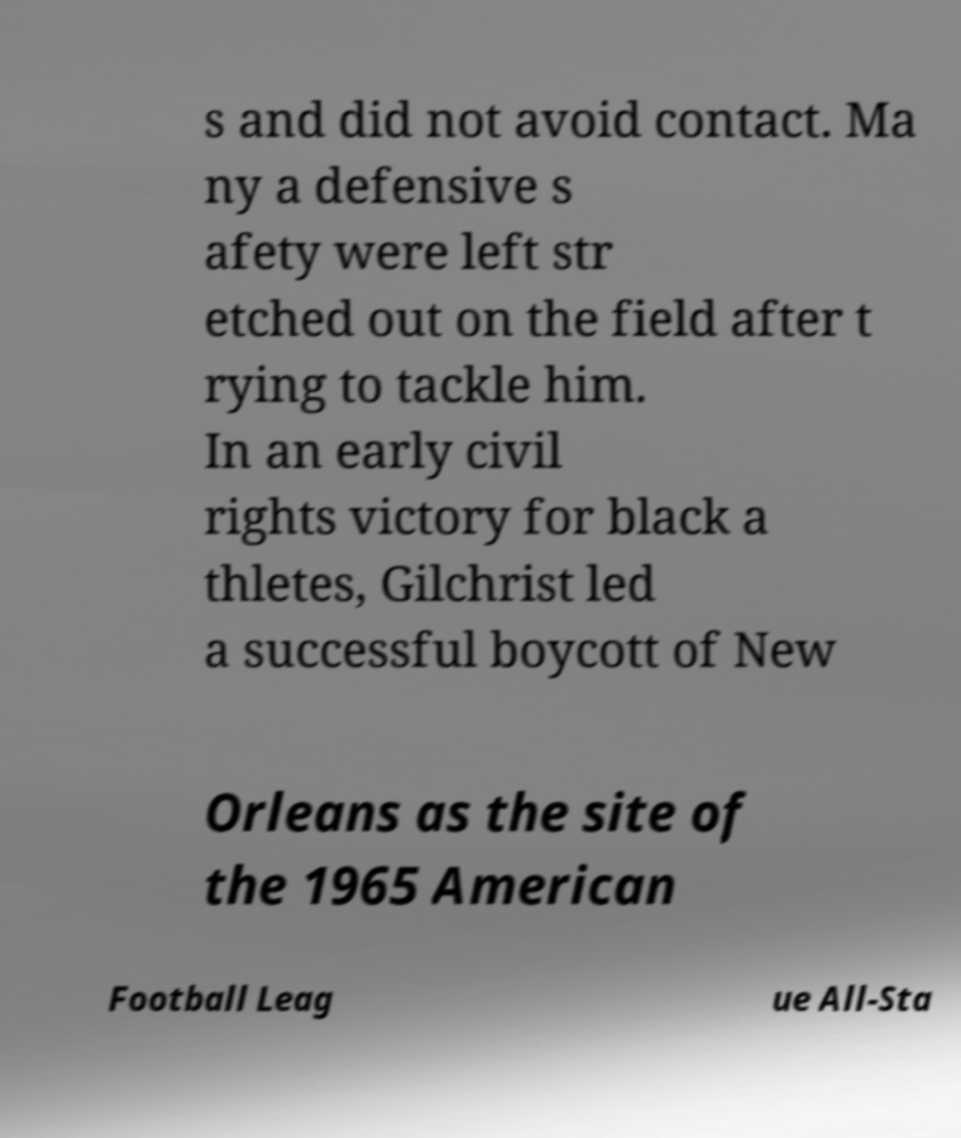What messages or text are displayed in this image? I need them in a readable, typed format. s and did not avoid contact. Ma ny a defensive s afety were left str etched out on the field after t rying to tackle him. In an early civil rights victory for black a thletes, Gilchrist led a successful boycott of New Orleans as the site of the 1965 American Football Leag ue All-Sta 